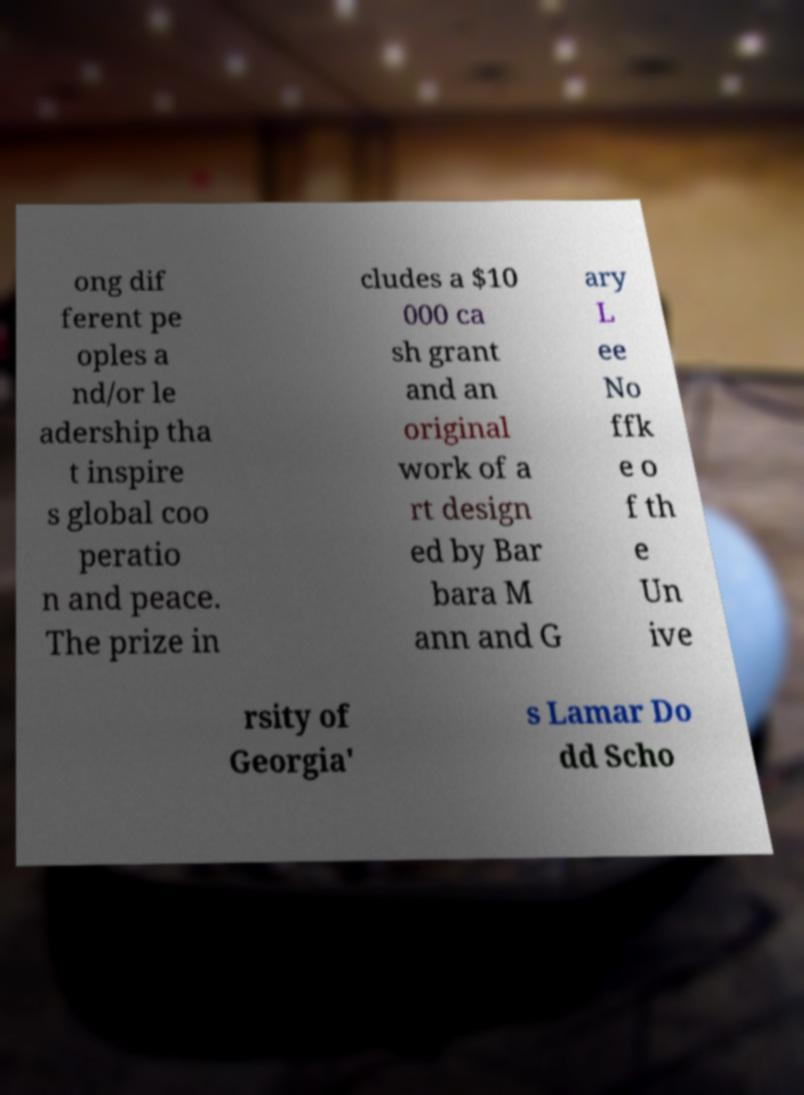Could you assist in decoding the text presented in this image and type it out clearly? ong dif ferent pe oples a nd/or le adership tha t inspire s global coo peratio n and peace. The prize in cludes a $10 000 ca sh grant and an original work of a rt design ed by Bar bara M ann and G ary L ee No ffk e o f th e Un ive rsity of Georgia' s Lamar Do dd Scho 